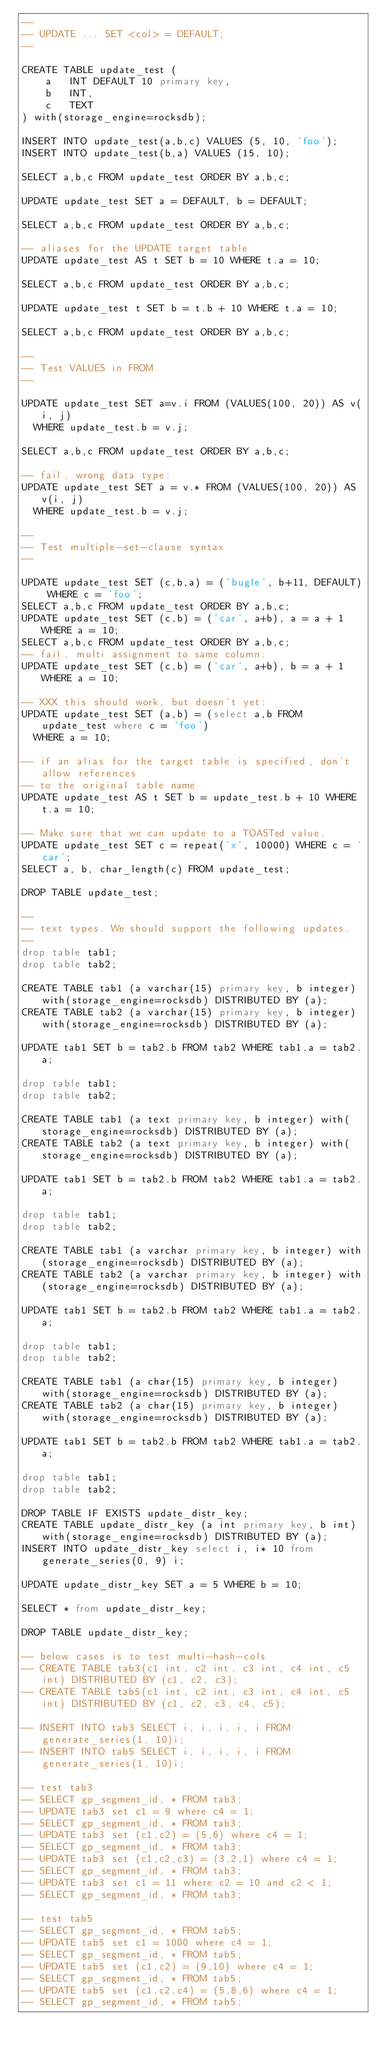Convert code to text. <code><loc_0><loc_0><loc_500><loc_500><_SQL_>--
-- UPDATE ... SET <col> = DEFAULT;
--

CREATE TABLE update_test (
    a   INT DEFAULT 10 primary key,
    b   INT,
    c   TEXT
) with(storage_engine=rocksdb);

INSERT INTO update_test(a,b,c) VALUES (5, 10, 'foo');
INSERT INTO update_test(b,a) VALUES (15, 10);

SELECT a,b,c FROM update_test ORDER BY a,b,c;

UPDATE update_test SET a = DEFAULT, b = DEFAULT;

SELECT a,b,c FROM update_test ORDER BY a,b,c;

-- aliases for the UPDATE target table
UPDATE update_test AS t SET b = 10 WHERE t.a = 10;

SELECT a,b,c FROM update_test ORDER BY a,b,c;

UPDATE update_test t SET b = t.b + 10 WHERE t.a = 10;

SELECT a,b,c FROM update_test ORDER BY a,b,c;

--
-- Test VALUES in FROM
--

UPDATE update_test SET a=v.i FROM (VALUES(100, 20)) AS v(i, j)
  WHERE update_test.b = v.j;

SELECT a,b,c FROM update_test ORDER BY a,b,c;

-- fail, wrong data type:
UPDATE update_test SET a = v.* FROM (VALUES(100, 20)) AS v(i, j)
  WHERE update_test.b = v.j;

--
-- Test multiple-set-clause syntax
--

UPDATE update_test SET (c,b,a) = ('bugle', b+11, DEFAULT) WHERE c = 'foo';
SELECT a,b,c FROM update_test ORDER BY a,b,c;
UPDATE update_test SET (c,b) = ('car', a+b), a = a + 1 WHERE a = 10;
SELECT a,b,c FROM update_test ORDER BY a,b,c;
-- fail, multi assignment to same column:
UPDATE update_test SET (c,b) = ('car', a+b), b = a + 1 WHERE a = 10;

-- XXX this should work, but doesn't yet:
UPDATE update_test SET (a,b) = (select a,b FROM update_test where c = 'foo')
  WHERE a = 10;

-- if an alias for the target table is specified, don't allow references
-- to the original table name
UPDATE update_test AS t SET b = update_test.b + 10 WHERE t.a = 10;

-- Make sure that we can update to a TOASTed value.
UPDATE update_test SET c = repeat('x', 10000) WHERE c = 'car';
SELECT a, b, char_length(c) FROM update_test;

DROP TABLE update_test;

--
-- text types. We should support the following updates.
--
drop table tab1;
drop table tab2;

CREATE TABLE tab1 (a varchar(15) primary key, b integer) with(storage_engine=rocksdb) DISTRIBUTED BY (a);
CREATE TABLE tab2 (a varchar(15) primary key, b integer) with(storage_engine=rocksdb) DISTRIBUTED BY (a);

UPDATE tab1 SET b = tab2.b FROM tab2 WHERE tab1.a = tab2.a;

drop table tab1;
drop table tab2;

CREATE TABLE tab1 (a text primary key, b integer) with(storage_engine=rocksdb) DISTRIBUTED BY (a);
CREATE TABLE tab2 (a text primary key, b integer) with(storage_engine=rocksdb) DISTRIBUTED BY (a);

UPDATE tab1 SET b = tab2.b FROM tab2 WHERE tab1.a = tab2.a;

drop table tab1;
drop table tab2;

CREATE TABLE tab1 (a varchar primary key, b integer) with(storage_engine=rocksdb) DISTRIBUTED BY (a);
CREATE TABLE tab2 (a varchar primary key, b integer) with(storage_engine=rocksdb) DISTRIBUTED BY (a);

UPDATE tab1 SET b = tab2.b FROM tab2 WHERE tab1.a = tab2.a;

drop table tab1;
drop table tab2;

CREATE TABLE tab1 (a char(15) primary key, b integer) with(storage_engine=rocksdb) DISTRIBUTED BY (a);
CREATE TABLE tab2 (a char(15) primary key, b integer) with(storage_engine=rocksdb) DISTRIBUTED BY (a);

UPDATE tab1 SET b = tab2.b FROM tab2 WHERE tab1.a = tab2.a;

drop table tab1;
drop table tab2;

DROP TABLE IF EXISTS update_distr_key; 
CREATE TABLE update_distr_key (a int primary key, b int) with(storage_engine=rocksdb) DISTRIBUTED BY (a); 
INSERT INTO update_distr_key select i, i* 10 from generate_series(0, 9) i; 

UPDATE update_distr_key SET a = 5 WHERE b = 10; 

SELECT * from update_distr_key; 

DROP TABLE update_distr_key;

-- below cases is to test multi-hash-cols
-- CREATE TABLE tab3(c1 int, c2 int, c3 int, c4 int, c5 int) DISTRIBUTED BY (c1, c2, c3);
-- CREATE TABLE tab5(c1 int, c2 int, c3 int, c4 int, c5 int) DISTRIBUTED BY (c1, c2, c3, c4, c5);

-- INSERT INTO tab3 SELECT i, i, i, i, i FROM generate_series(1, 10)i;
-- INSERT INTO tab5 SELECT i, i, i, i, i FROM generate_series(1, 10)i;

-- test tab3
-- SELECT gp_segment_id, * FROM tab3;
-- UPDATE tab3 set c1 = 9 where c4 = 1;
-- SELECT gp_segment_id, * FROM tab3;
-- UPDATE tab3 set (c1,c2) = (5,6) where c4 = 1;
-- SELECT gp_segment_id, * FROM tab3;
-- UPDATE tab3 set (c1,c2,c3) = (3,2,1) where c4 = 1;
-- SELECT gp_segment_id, * FROM tab3;
-- UPDATE tab3 set c1 = 11 where c2 = 10 and c2 < 1;
-- SELECT gp_segment_id, * FROM tab3;

-- test tab5
-- SELECT gp_segment_id, * FROM tab5;
-- UPDATE tab5 set c1 = 1000 where c4 = 1;
-- SELECT gp_segment_id, * FROM tab5;
-- UPDATE tab5 set (c1,c2) = (9,10) where c4 = 1;
-- SELECT gp_segment_id, * FROM tab5;
-- UPDATE tab5 set (c1,c2,c4) = (5,8,6) where c4 = 1;
-- SELECT gp_segment_id, * FROM tab5;</code> 